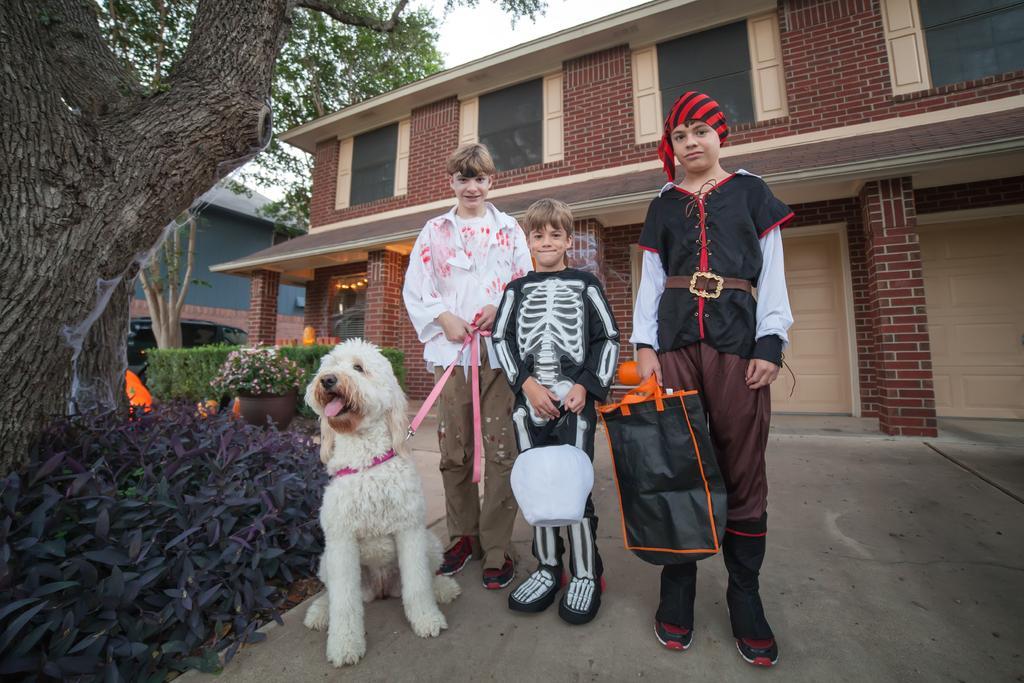Could you give a brief overview of what you see in this image? In this image there are three boys standing in front of a building. They are wearing costumes. Here there is a dog tied with a rope. On the left there are trees, plants. Here there is a car. In the background there trees, building. 